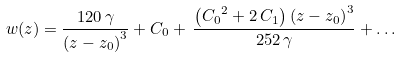Convert formula to latex. <formula><loc_0><loc_0><loc_500><loc_500>w ( z ) = { \frac { 1 2 0 \, \gamma } { { ( z - z _ { 0 } ) } ^ { 3 } } } + { C _ { 0 } } + \, { \frac { \left ( { C _ { 0 } } ^ { 2 } + 2 \, { C _ { 1 } } \right ) { ( z - z _ { 0 } ) } ^ { 3 } } { 2 5 2 \, \gamma } } + \dots</formula> 